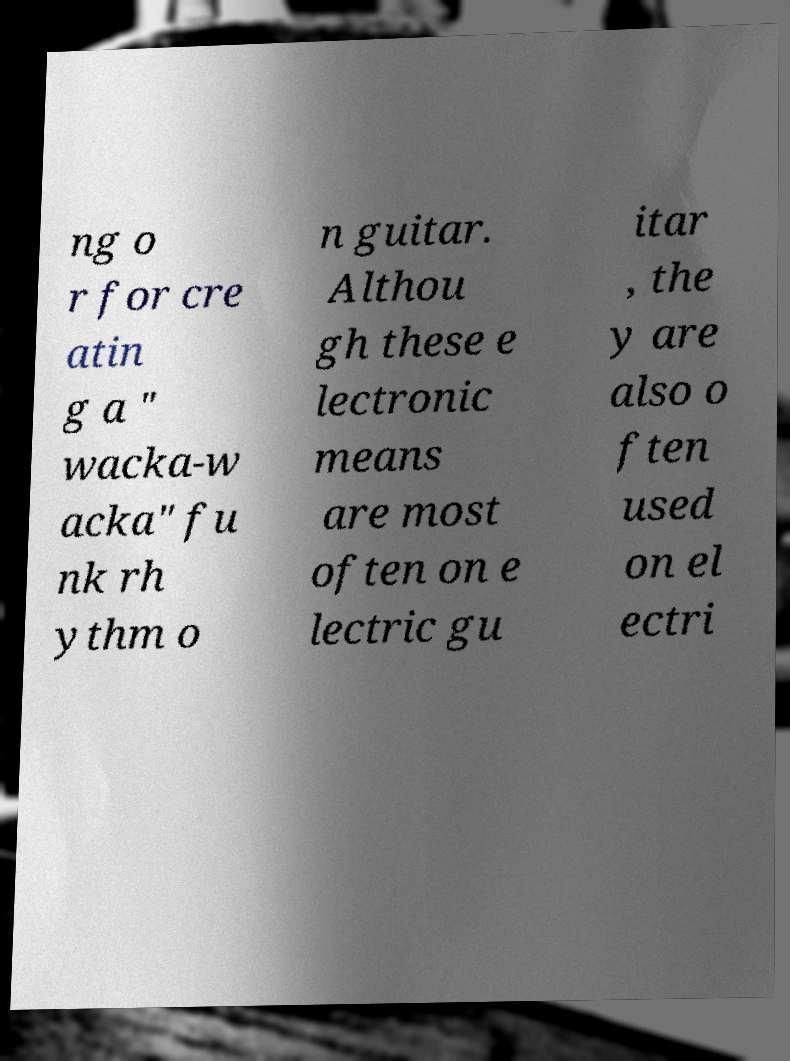For documentation purposes, I need the text within this image transcribed. Could you provide that? ng o r for cre atin g a " wacka-w acka" fu nk rh ythm o n guitar. Althou gh these e lectronic means are most often on e lectric gu itar , the y are also o ften used on el ectri 